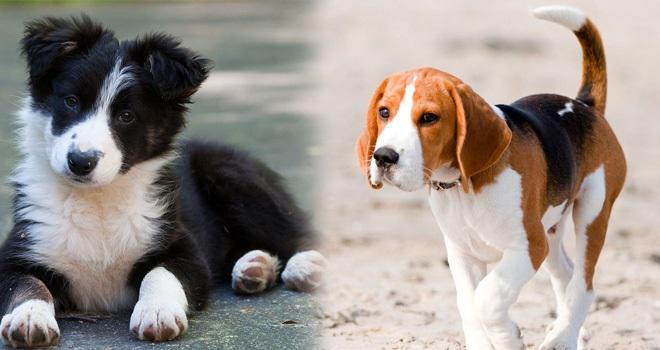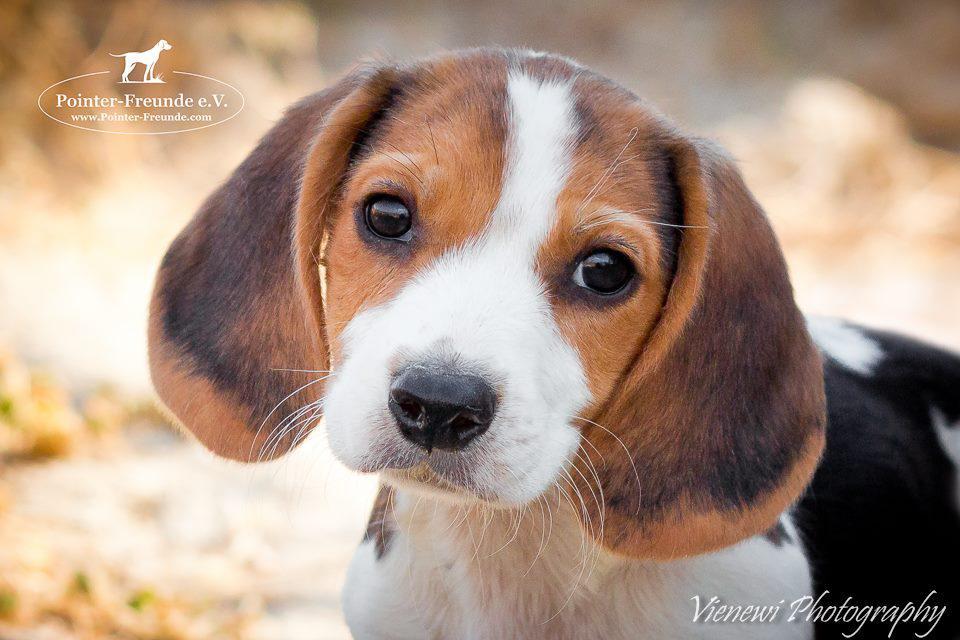The first image is the image on the left, the second image is the image on the right. Given the left and right images, does the statement "An image includes a standing dog with its tail upright and curved inward." hold true? Answer yes or no. Yes. The first image is the image on the left, the second image is the image on the right. Analyze the images presented: Is the assertion "One dog in the image on the left is standing up on all fours." valid? Answer yes or no. Yes. 